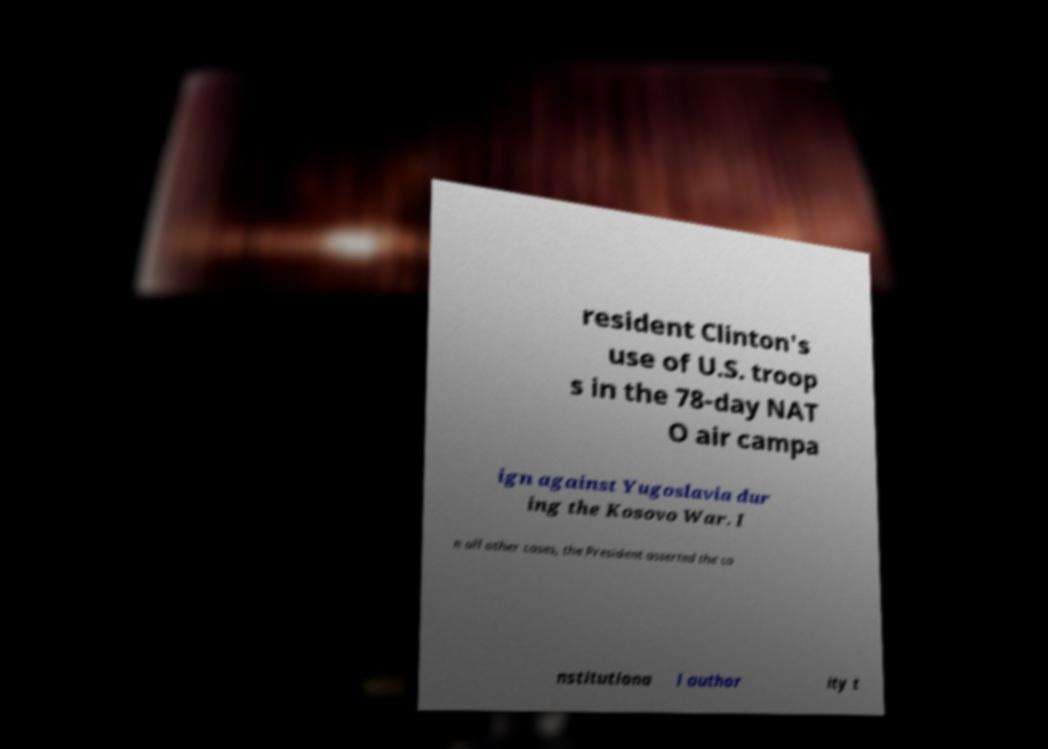Please read and relay the text visible in this image. What does it say? resident Clinton's use of U.S. troop s in the 78-day NAT O air campa ign against Yugoslavia dur ing the Kosovo War. I n all other cases, the President asserted the co nstitutiona l author ity t 